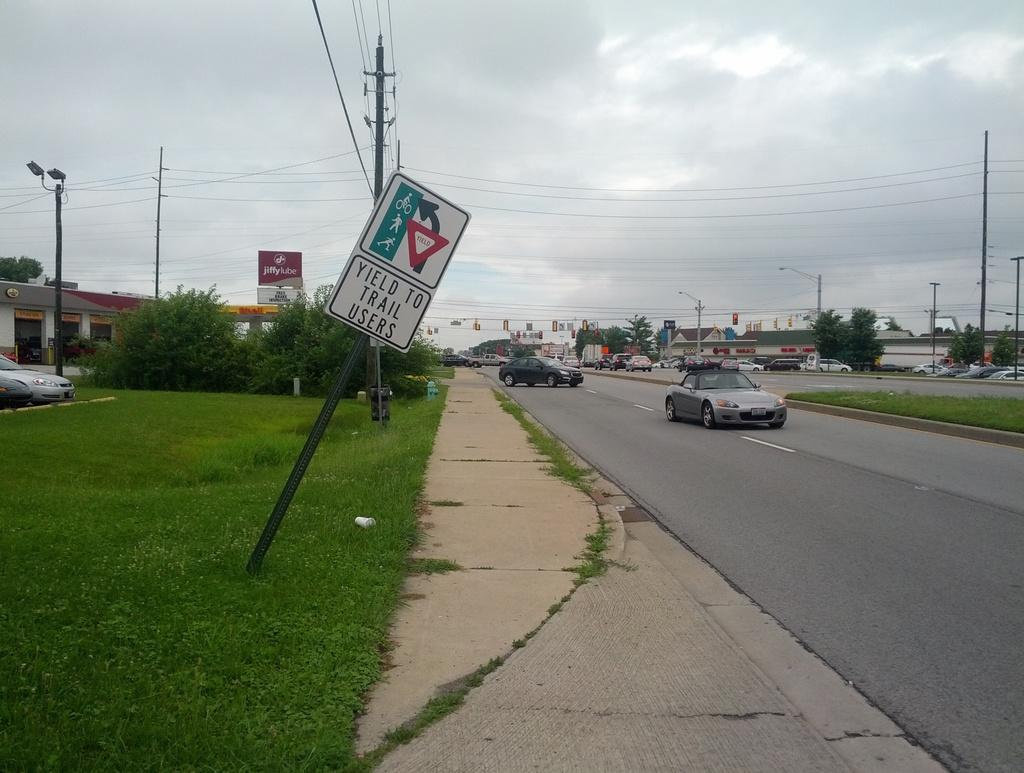<image>
Write a terse but informative summary of the picture. To cars on a road with a sidewalk and grass to the left and a sign reading Yield to Trail Users slanted on the grass 